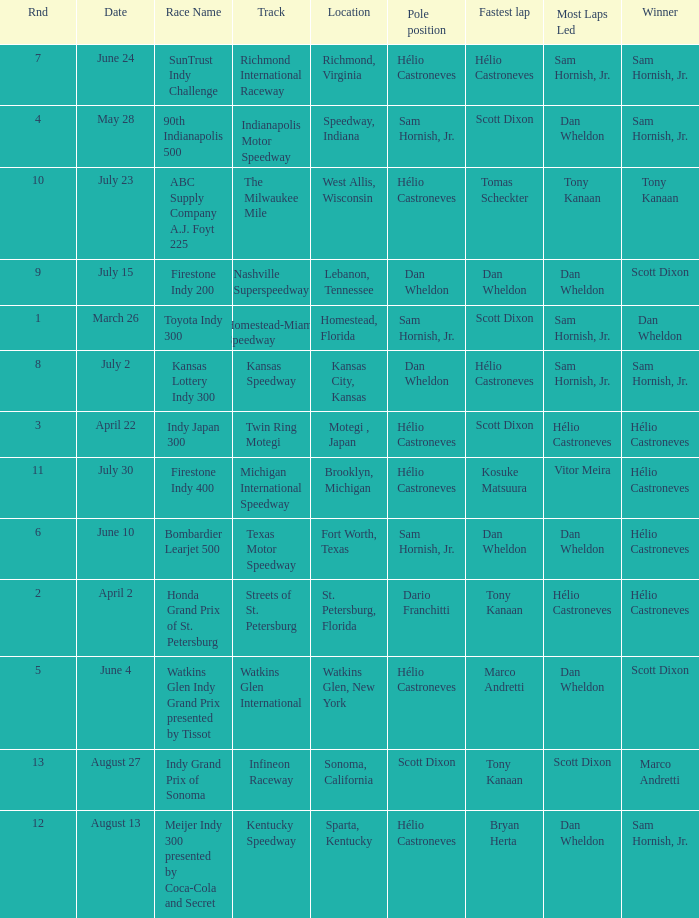How many times is the location is homestead, florida? 1.0. 